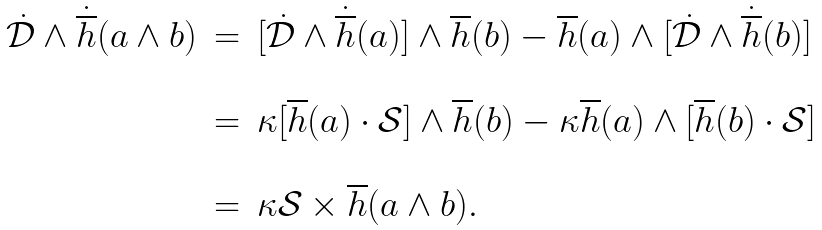Convert formula to latex. <formula><loc_0><loc_0><loc_500><loc_500>\begin{array} { r c l } \dot { \mathcal { D } } \wedge \dot { \overline { h } } ( a \wedge b ) & = & [ \dot { \mathcal { D } } \wedge \dot { \overline { h } } ( a ) ] \wedge \overline { h } ( b ) - \overline { h } ( a ) \wedge [ \dot { \mathcal { D } } \wedge \dot { \overline { h } } ( b ) ] \\ \\ & = & \kappa [ \overline { h } ( a ) \cdot \mathcal { S } ] \wedge \overline { h } ( b ) - \kappa \overline { h } ( a ) \wedge [ \overline { h } ( b ) \cdot \mathcal { S } ] \\ \\ & = & \kappa \mathcal { S } \times \overline { h } ( a \wedge b ) . \end{array}</formula> 